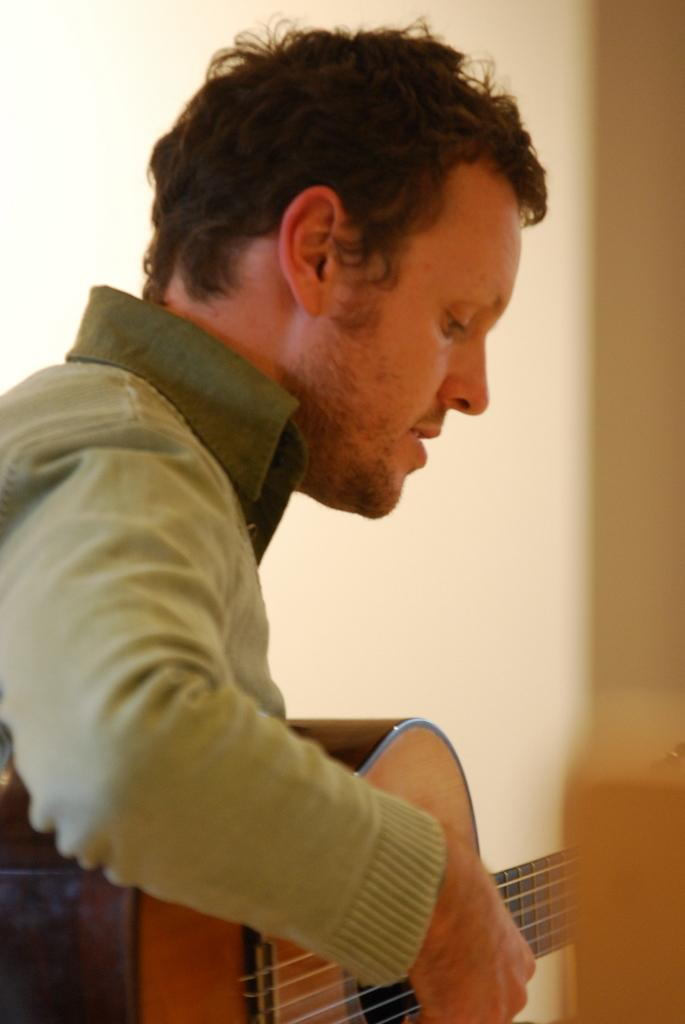Who is the person in the image? There is a man in the image. What is the man holding in the image? The man is holding a guitar. What is the man doing with the guitar? The man is playing the guitar. What can be seen in the background of the image? There is a wall in the background of the image. What is the man's journey through space like in the image? There is no reference to space or a journey in the image; it features a man playing a guitar with a wall in the background. 